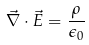<formula> <loc_0><loc_0><loc_500><loc_500>\vec { \nabla } \cdot \vec { E } = \frac { \rho } { \epsilon _ { 0 } }</formula> 